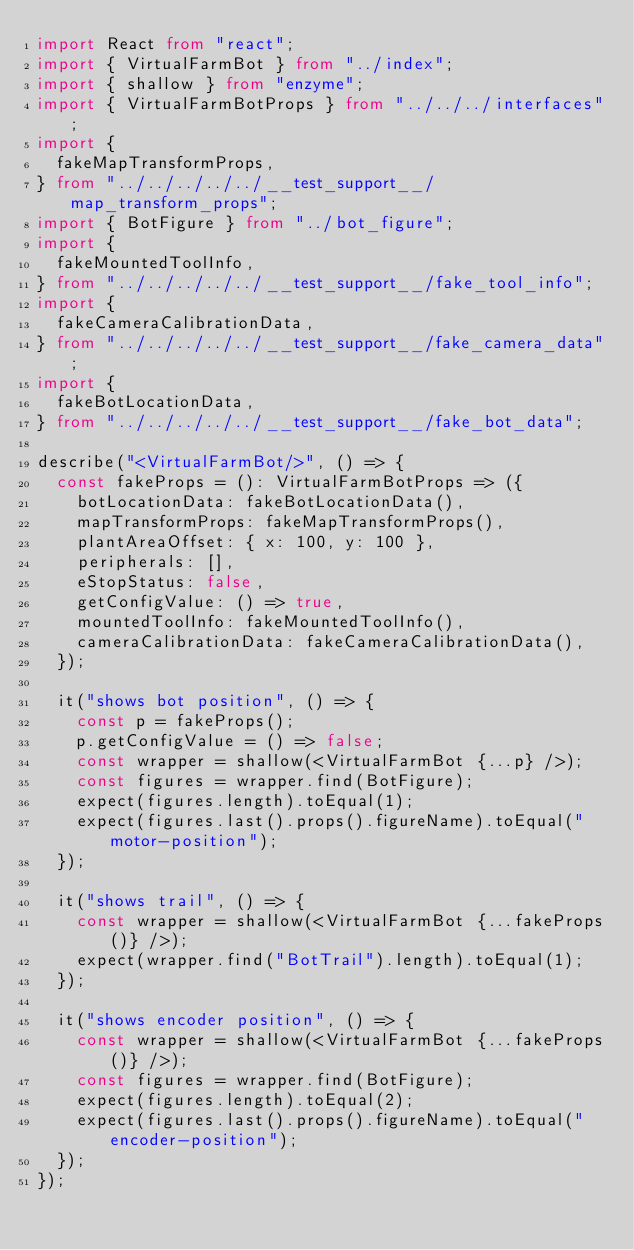<code> <loc_0><loc_0><loc_500><loc_500><_TypeScript_>import React from "react";
import { VirtualFarmBot } from "../index";
import { shallow } from "enzyme";
import { VirtualFarmBotProps } from "../../../interfaces";
import {
  fakeMapTransformProps,
} from "../../../../../__test_support__/map_transform_props";
import { BotFigure } from "../bot_figure";
import {
  fakeMountedToolInfo,
} from "../../../../../__test_support__/fake_tool_info";
import {
  fakeCameraCalibrationData,
} from "../../../../../__test_support__/fake_camera_data";
import {
  fakeBotLocationData,
} from "../../../../../__test_support__/fake_bot_data";

describe("<VirtualFarmBot/>", () => {
  const fakeProps = (): VirtualFarmBotProps => ({
    botLocationData: fakeBotLocationData(),
    mapTransformProps: fakeMapTransformProps(),
    plantAreaOffset: { x: 100, y: 100 },
    peripherals: [],
    eStopStatus: false,
    getConfigValue: () => true,
    mountedToolInfo: fakeMountedToolInfo(),
    cameraCalibrationData: fakeCameraCalibrationData(),
  });

  it("shows bot position", () => {
    const p = fakeProps();
    p.getConfigValue = () => false;
    const wrapper = shallow(<VirtualFarmBot {...p} />);
    const figures = wrapper.find(BotFigure);
    expect(figures.length).toEqual(1);
    expect(figures.last().props().figureName).toEqual("motor-position");
  });

  it("shows trail", () => {
    const wrapper = shallow(<VirtualFarmBot {...fakeProps()} />);
    expect(wrapper.find("BotTrail").length).toEqual(1);
  });

  it("shows encoder position", () => {
    const wrapper = shallow(<VirtualFarmBot {...fakeProps()} />);
    const figures = wrapper.find(BotFigure);
    expect(figures.length).toEqual(2);
    expect(figures.last().props().figureName).toEqual("encoder-position");
  });
});
</code> 